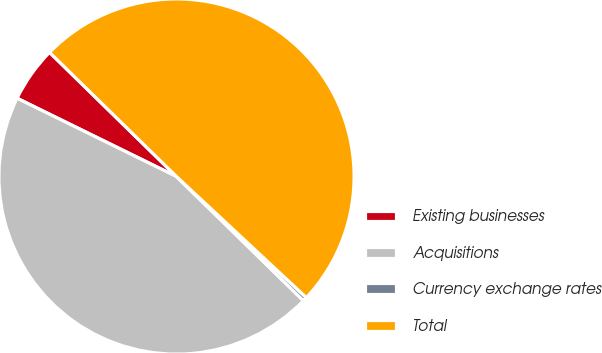Convert chart to OTSL. <chart><loc_0><loc_0><loc_500><loc_500><pie_chart><fcel>Existing businesses<fcel>Acquisitions<fcel>Currency exchange rates<fcel>Total<nl><fcel>5.06%<fcel>44.94%<fcel>0.38%<fcel>49.62%<nl></chart> 